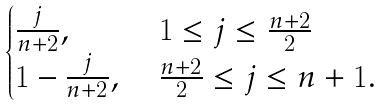Convert formula to latex. <formula><loc_0><loc_0><loc_500><loc_500>\begin{cases} \frac { j } { n + 2 } , & \text { $1\leq j \leq \frac{n+2}{2}$} \\ 1 - \frac { j } { n + 2 } , & \text { $ \frac{n+2}{2}\leq j \leq {n+1}$} . \end{cases}</formula> 